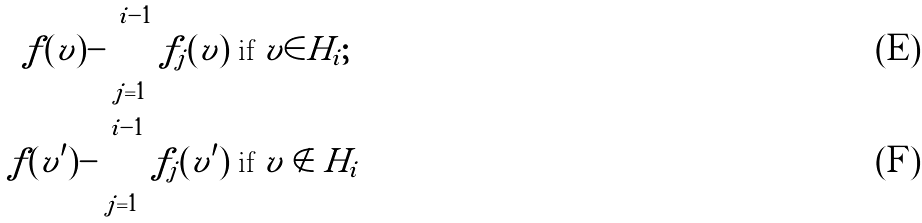Convert formula to latex. <formula><loc_0><loc_0><loc_500><loc_500>f ( v ) - \sum _ { j = 1 } ^ { i - 1 } f _ { j } ( v ) & \text { if } v \in H _ { i } ; \\ f ( v ^ { \prime } ) - \sum _ { j = 1 } ^ { i - 1 } f _ { j } ( v ^ { \prime } ) & \text { if } v \notin H _ { i }</formula> 